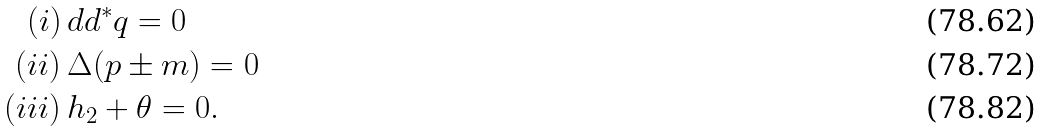<formula> <loc_0><loc_0><loc_500><loc_500>( i ) \, & d d ^ { * } q = 0 \\ ( i i ) \, & \Delta ( p \pm m ) = 0 \\ ( i i i ) \, & h _ { 2 } + \theta = 0 .</formula> 